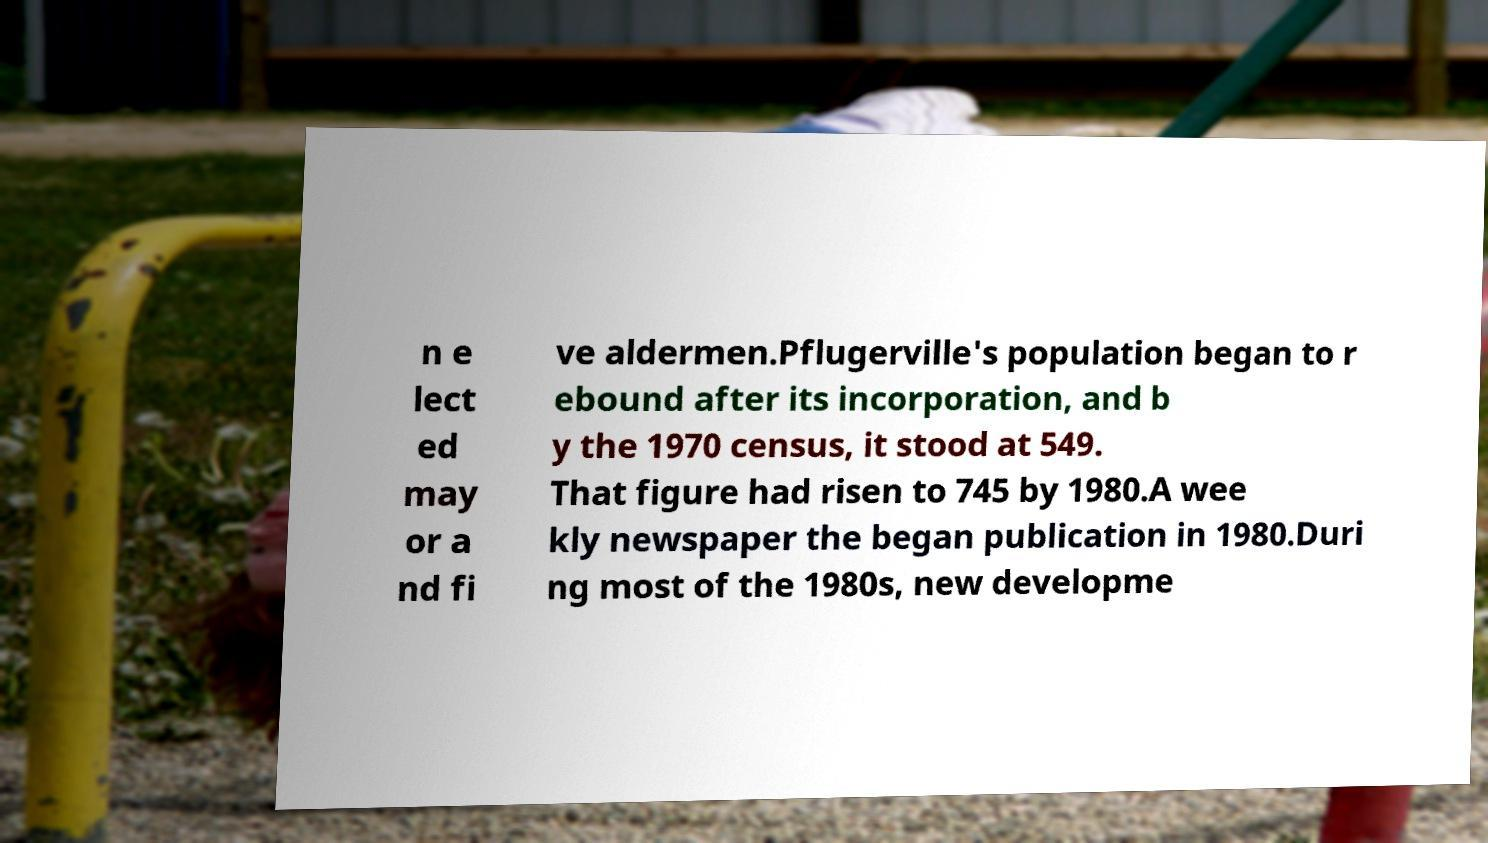Could you assist in decoding the text presented in this image and type it out clearly? n e lect ed may or a nd fi ve aldermen.Pflugerville's population began to r ebound after its incorporation, and b y the 1970 census, it stood at 549. That figure had risen to 745 by 1980.A wee kly newspaper the began publication in 1980.Duri ng most of the 1980s, new developme 